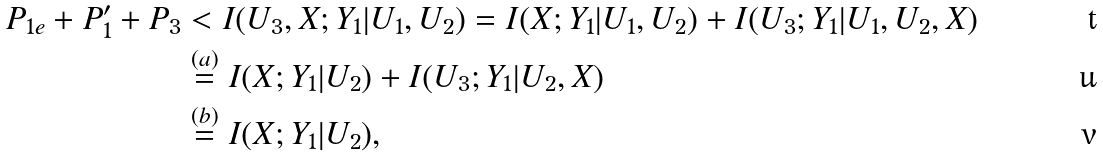<formula> <loc_0><loc_0><loc_500><loc_500>P _ { 1 e } + P _ { 1 } ^ { \prime } + P _ { 3 } & < I ( U _ { 3 } , X ; Y _ { 1 } | U _ { 1 } , U _ { 2 } ) = I ( X ; Y _ { 1 } | U _ { 1 } , U _ { 2 } ) + I ( U _ { 3 } ; Y _ { 1 } | U _ { 1 } , U _ { 2 } , X ) \\ & \stackrel { ( a ) } { = } I ( X ; Y _ { 1 } | U _ { 2 } ) + I ( U _ { 3 } ; Y _ { 1 } | U _ { 2 } , X ) \\ & \stackrel { ( b ) } { = } I ( X ; Y _ { 1 } | U _ { 2 } ) ,</formula> 